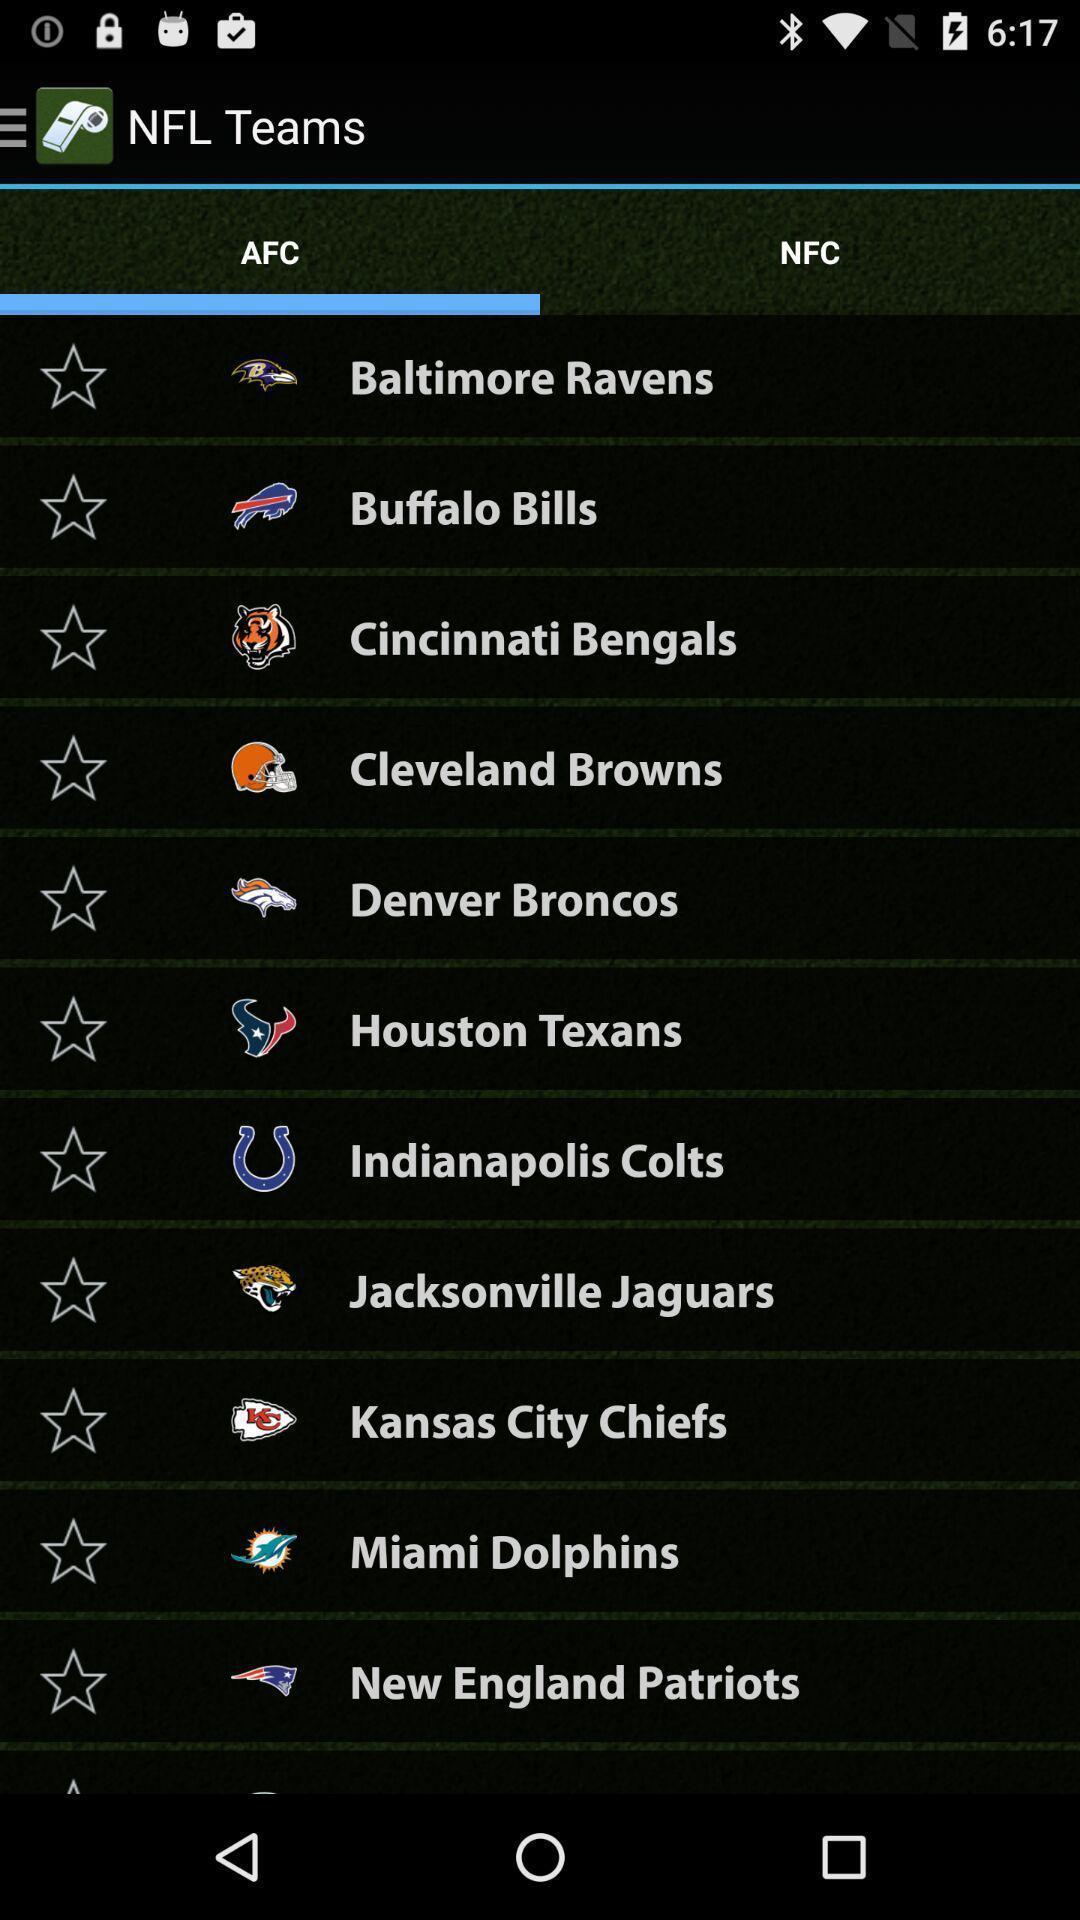Describe the content in this image. Screen shows different teams of a selected group. 